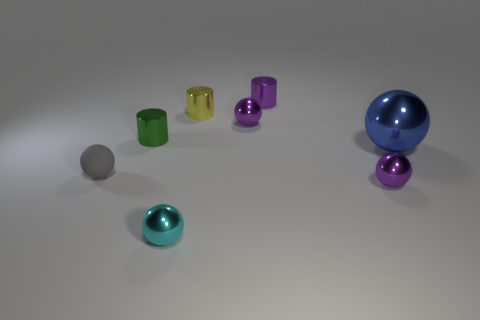What is the shape of the gray object that is the same size as the yellow metallic cylinder?
Offer a terse response. Sphere. There is a small matte thing; is it the same color as the small ball behind the tiny green metal object?
Your answer should be very brief. No. There is a small purple metal object right of the purple shiny cylinder; how many yellow things are in front of it?
Give a very brief answer. 0. What is the size of the ball that is both to the left of the yellow object and right of the gray rubber ball?
Provide a succinct answer. Small. Is there a green metallic cylinder of the same size as the yellow metal object?
Provide a short and direct response. Yes. Are there more small green metal cylinders in front of the tiny gray object than large objects in front of the small cyan ball?
Ensure brevity in your answer.  No. Do the yellow thing and the tiny purple sphere that is in front of the big object have the same material?
Your answer should be compact. Yes. How many small yellow cylinders are right of the thing on the right side of the small purple metal sphere in front of the small gray matte ball?
Your answer should be very brief. 0. There is a large shiny thing; does it have the same shape as the small shiny object left of the small cyan sphere?
Make the answer very short. No. There is a small cylinder that is in front of the tiny purple cylinder and behind the green shiny object; what is its color?
Make the answer very short. Yellow. 